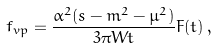Convert formula to latex. <formula><loc_0><loc_0><loc_500><loc_500>f _ { v p } = \frac { \alpha ^ { 2 } ( s - m ^ { 2 } - \mu ^ { 2 } ) } { 3 \pi W t } F ( t ) \, ,</formula> 